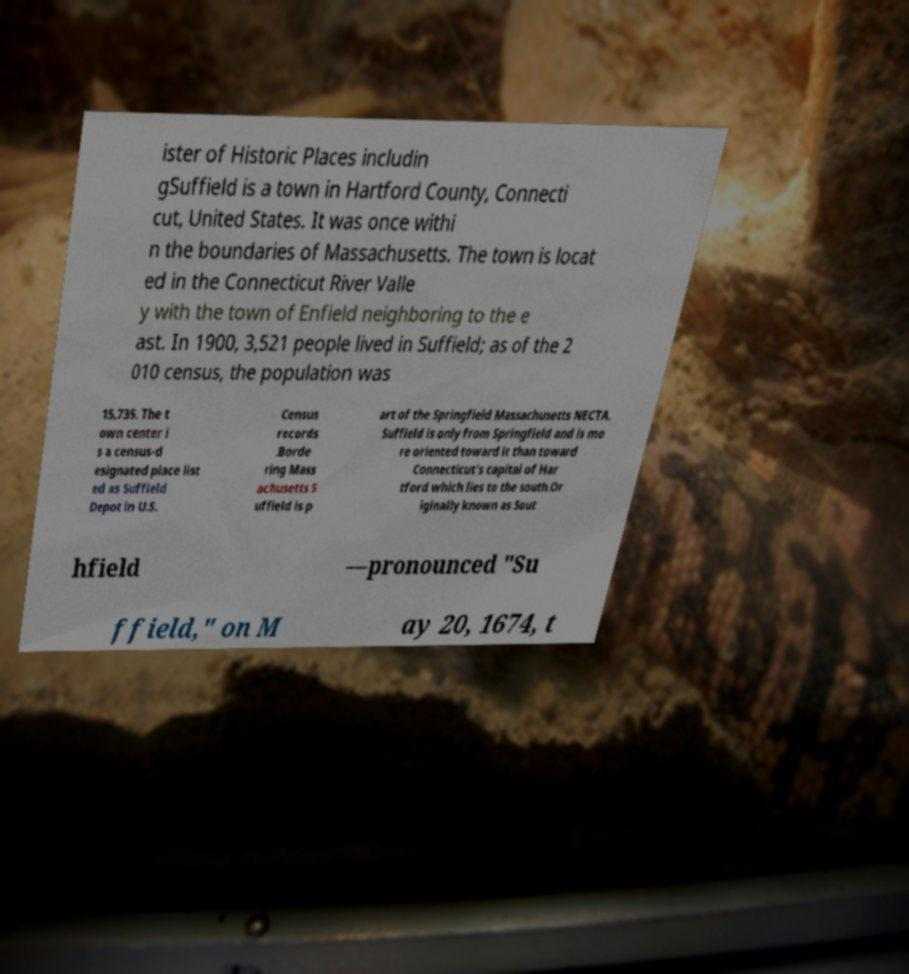Please read and relay the text visible in this image. What does it say? ister of Historic Places includin gSuffield is a town in Hartford County, Connecti cut, United States. It was once withi n the boundaries of Massachusetts. The town is locat ed in the Connecticut River Valle y with the town of Enfield neighboring to the e ast. In 1900, 3,521 people lived in Suffield; as of the 2 010 census, the population was 15,735. The t own center i s a census-d esignated place list ed as Suffield Depot in U.S. Census records .Borde ring Mass achusetts S uffield is p art of the Springfield Massachusetts NECTA. Suffield is only from Springfield and is mo re oriented toward it than toward Connecticut's capital of Har tford which lies to the south.Or iginally known as Sout hfield —pronounced "Su ffield," on M ay 20, 1674, t 